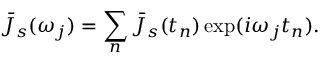<formula> <loc_0><loc_0><loc_500><loc_500>\bar { J } _ { s } ( \omega _ { j } ) = \sum _ { n } \bar { J } _ { s } ( t _ { n } ) \exp ( i \omega _ { j } t _ { n } ) .</formula> 